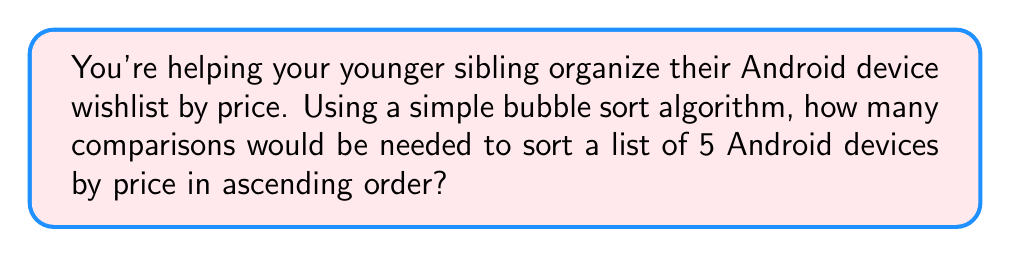Show me your answer to this math problem. Let's break this down step-by-step:

1) Bubble sort works by repeatedly stepping through the list, comparing adjacent elements and swapping them if they're in the wrong order.

2) In the worst-case scenario (when the list is in reverse order), bubble sort needs to make:
   $$(n-1) + (n-2) + (n-3) + ... + 2 + 1$$ comparisons, where $n$ is the number of items.

3) This sum can be represented by the formula:
   $$\frac{n(n-1)}{2}$$

4) In this case, $n = 5$ (5 Android devices).

5) Plugging this into our formula:
   $$\frac{5(5-1)}{2} = \frac{5(4)}{2} = \frac{20}{2} = 10$$

Therefore, in the worst-case scenario, 10 comparisons would be needed to sort the list of 5 Android devices by price.
Answer: 10 comparisons 